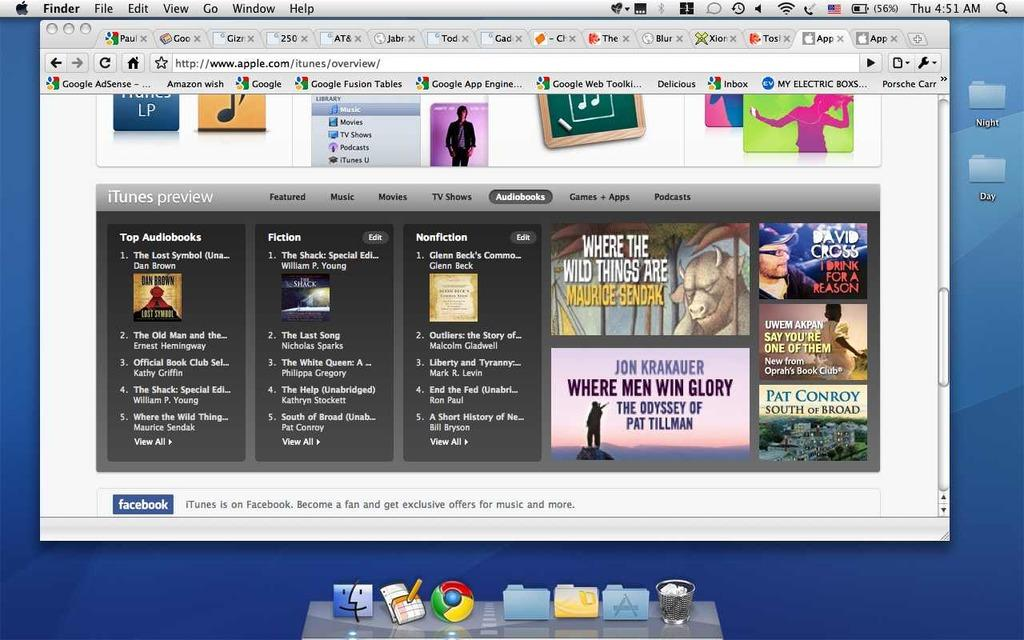<image>
Offer a succinct explanation of the picture presented. The website that is shown here is Apple 